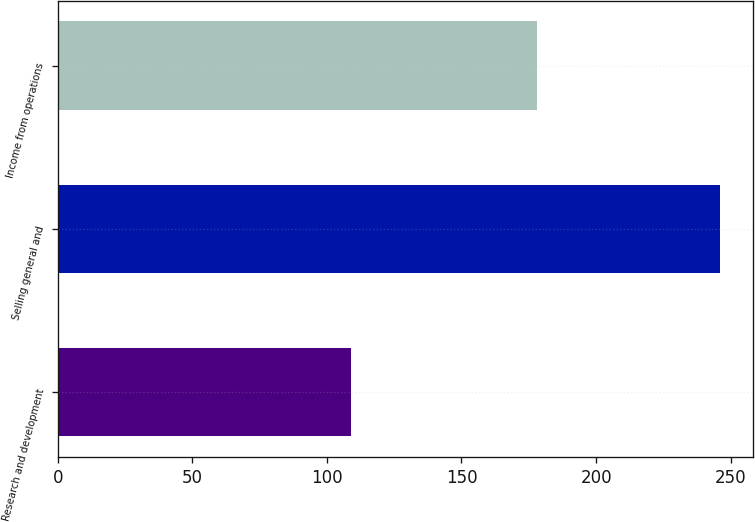Convert chart to OTSL. <chart><loc_0><loc_0><loc_500><loc_500><bar_chart><fcel>Research and development<fcel>Selling general and<fcel>Income from operations<nl><fcel>109<fcel>246<fcel>178<nl></chart> 